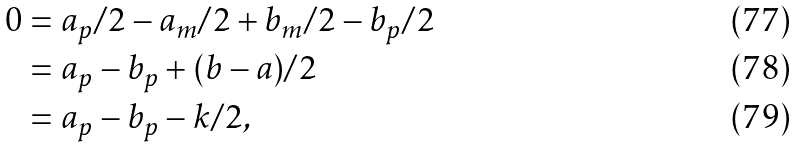Convert formula to latex. <formula><loc_0><loc_0><loc_500><loc_500>0 & = a _ { p } / 2 - a _ { m } / 2 + b _ { m } / 2 - b _ { p } / 2 \\ & = a _ { p } - b _ { p } + ( b - a ) / 2 \\ & = a _ { p } - b _ { p } - k / 2 ,</formula> 